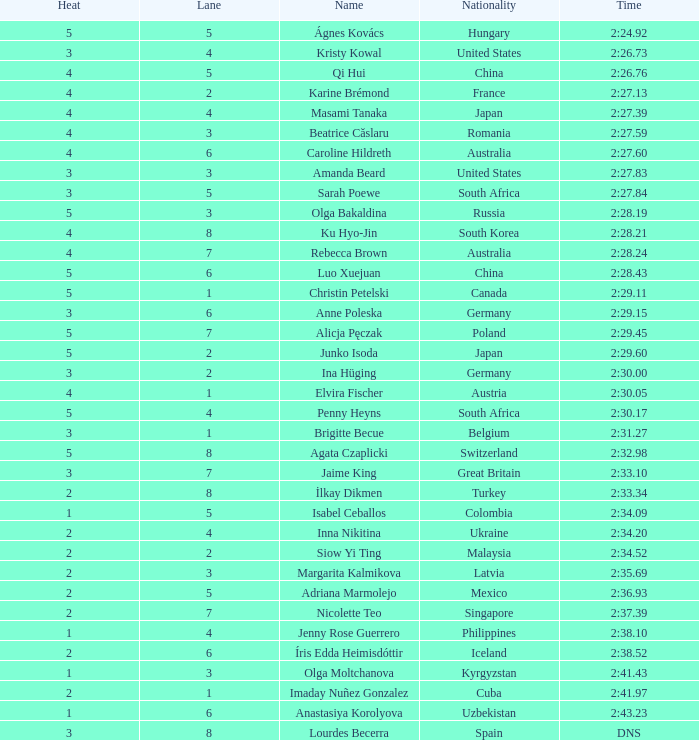Parse the table in full. {'header': ['Heat', 'Lane', 'Name', 'Nationality', 'Time'], 'rows': [['5', '5', 'Ágnes Kovács', 'Hungary', '2:24.92'], ['3', '4', 'Kristy Kowal', 'United States', '2:26.73'], ['4', '5', 'Qi Hui', 'China', '2:26.76'], ['4', '2', 'Karine Brémond', 'France', '2:27.13'], ['4', '4', 'Masami Tanaka', 'Japan', '2:27.39'], ['4', '3', 'Beatrice Căslaru', 'Romania', '2:27.59'], ['4', '6', 'Caroline Hildreth', 'Australia', '2:27.60'], ['3', '3', 'Amanda Beard', 'United States', '2:27.83'], ['3', '5', 'Sarah Poewe', 'South Africa', '2:27.84'], ['5', '3', 'Olga Bakaldina', 'Russia', '2:28.19'], ['4', '8', 'Ku Hyo-Jin', 'South Korea', '2:28.21'], ['4', '7', 'Rebecca Brown', 'Australia', '2:28.24'], ['5', '6', 'Luo Xuejuan', 'China', '2:28.43'], ['5', '1', 'Christin Petelski', 'Canada', '2:29.11'], ['3', '6', 'Anne Poleska', 'Germany', '2:29.15'], ['5', '7', 'Alicja Pęczak', 'Poland', '2:29.45'], ['5', '2', 'Junko Isoda', 'Japan', '2:29.60'], ['3', '2', 'Ina Hüging', 'Germany', '2:30.00'], ['4', '1', 'Elvira Fischer', 'Austria', '2:30.05'], ['5', '4', 'Penny Heyns', 'South Africa', '2:30.17'], ['3', '1', 'Brigitte Becue', 'Belgium', '2:31.27'], ['5', '8', 'Agata Czaplicki', 'Switzerland', '2:32.98'], ['3', '7', 'Jaime King', 'Great Britain', '2:33.10'], ['2', '8', 'İlkay Dikmen', 'Turkey', '2:33.34'], ['1', '5', 'Isabel Ceballos', 'Colombia', '2:34.09'], ['2', '4', 'Inna Nikitina', 'Ukraine', '2:34.20'], ['2', '2', 'Siow Yi Ting', 'Malaysia', '2:34.52'], ['2', '3', 'Margarita Kalmikova', 'Latvia', '2:35.69'], ['2', '5', 'Adriana Marmolejo', 'Mexico', '2:36.93'], ['2', '7', 'Nicolette Teo', 'Singapore', '2:37.39'], ['1', '4', 'Jenny Rose Guerrero', 'Philippines', '2:38.10'], ['2', '6', 'Íris Edda Heimisdóttir', 'Iceland', '2:38.52'], ['1', '3', 'Olga Moltchanova', 'Kyrgyzstan', '2:41.43'], ['2', '1', 'Imaday Nuñez Gonzalez', 'Cuba', '2:41.97'], ['1', '6', 'Anastasiya Korolyova', 'Uzbekistan', '2:43.23'], ['3', '8', 'Lourdes Becerra', 'Spain', 'DNS']]} What route did inna nikitina take? 4.0. 